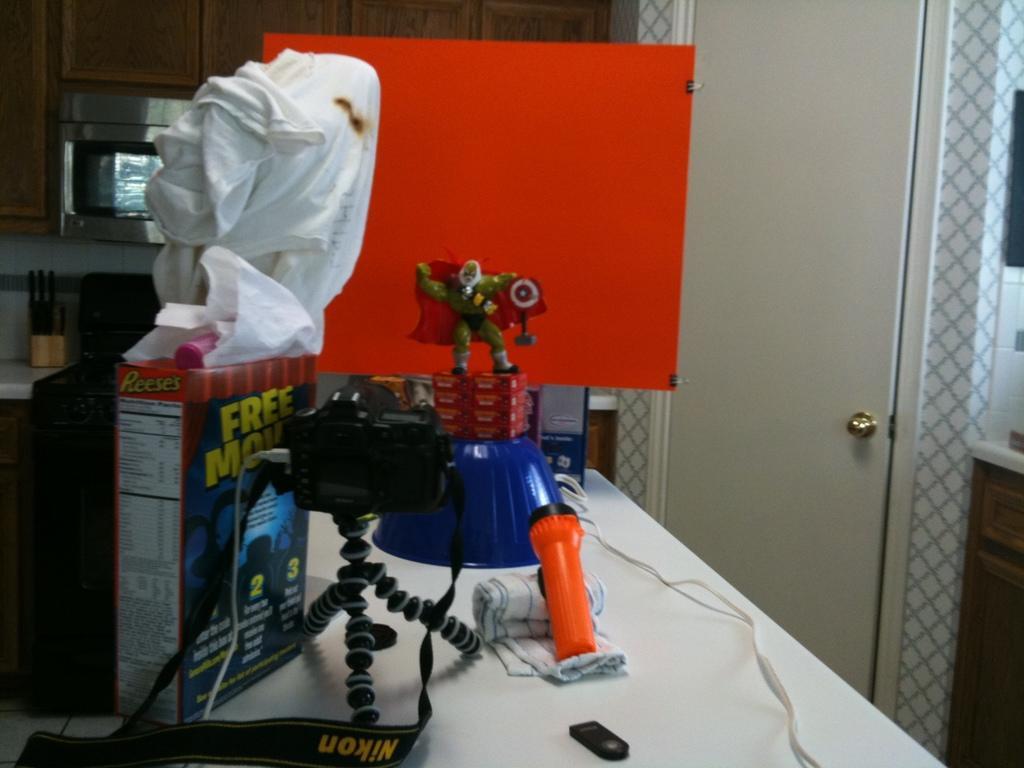Could you give a brief overview of what you see in this image? In this image I can see a camera,orange torch,box,toy and few objects on the white color table. I can see an orange color board,white door,cupboard,oven and few objects at back. 